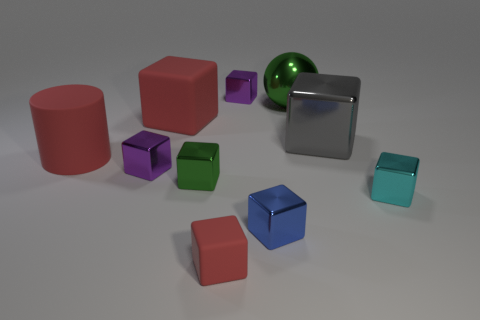Subtract all gray metal cubes. How many cubes are left? 7 Subtract 0 gray cylinders. How many objects are left? 10 Subtract all blocks. How many objects are left? 2 Subtract 2 blocks. How many blocks are left? 6 Subtract all brown balls. Subtract all brown blocks. How many balls are left? 1 Subtract all yellow balls. How many yellow cylinders are left? 0 Subtract all gray shiny spheres. Subtract all tiny green metallic blocks. How many objects are left? 9 Add 6 cyan objects. How many cyan objects are left? 7 Add 1 yellow metallic cylinders. How many yellow metallic cylinders exist? 1 Subtract all green blocks. How many blocks are left? 7 